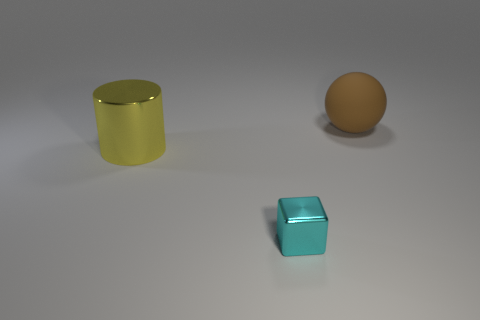Is there any other thing that is made of the same material as the sphere?
Your answer should be compact. No. What number of big shiny objects are on the left side of the big object to the right of the yellow cylinder?
Your answer should be compact. 1. Is the size of the block the same as the object that is behind the yellow cylinder?
Keep it short and to the point. No. Is there a yellow rubber sphere of the same size as the yellow metallic object?
Your answer should be very brief. No. What number of things are either yellow cylinders or tiny purple spheres?
Ensure brevity in your answer.  1. Does the shiny object behind the tiny cyan metallic object have the same size as the thing behind the big metallic cylinder?
Keep it short and to the point. Yes. Are there any large metallic things that have the same shape as the rubber thing?
Ensure brevity in your answer.  No. Is the number of cylinders in front of the cyan cube less than the number of tiny cyan matte balls?
Offer a very short reply. No. Does the matte object have the same shape as the large yellow thing?
Ensure brevity in your answer.  No. There is a shiny thing left of the tiny cyan shiny object; what size is it?
Provide a succinct answer. Large. 